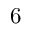<formula> <loc_0><loc_0><loc_500><loc_500>6</formula> 